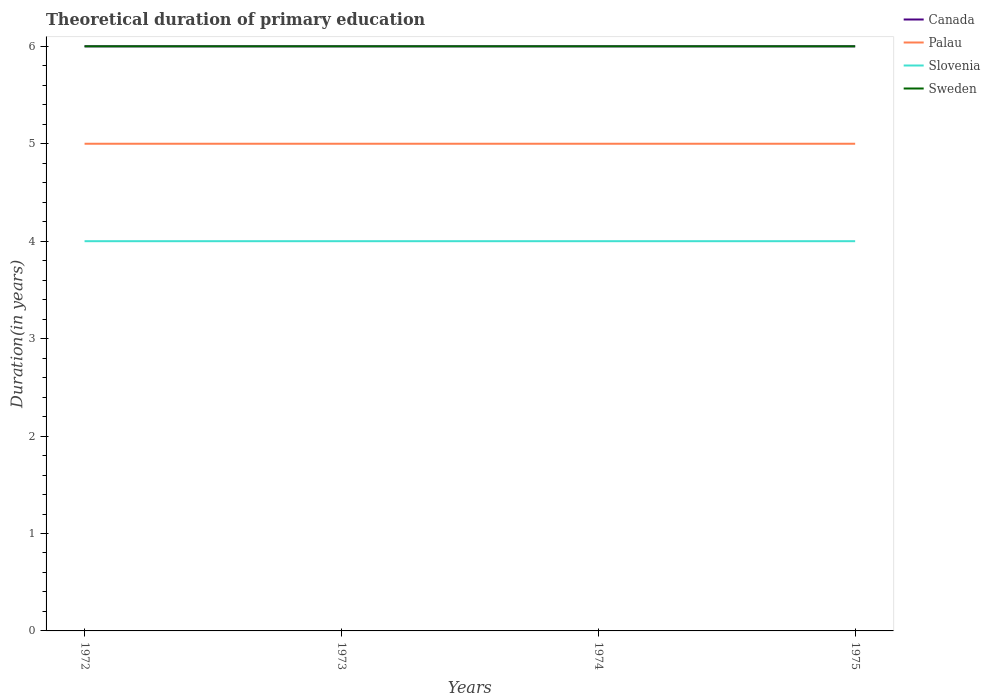How many different coloured lines are there?
Offer a terse response. 4. Does the line corresponding to Canada intersect with the line corresponding to Palau?
Your answer should be compact. No. Is the number of lines equal to the number of legend labels?
Your response must be concise. Yes. What is the total total theoretical duration of primary education in Canada in the graph?
Your answer should be compact. 0. What is the difference between the highest and the second highest total theoretical duration of primary education in Sweden?
Your answer should be compact. 0. What is the difference between the highest and the lowest total theoretical duration of primary education in Slovenia?
Your answer should be very brief. 0. Is the total theoretical duration of primary education in Slovenia strictly greater than the total theoretical duration of primary education in Palau over the years?
Your answer should be very brief. Yes. How many lines are there?
Offer a very short reply. 4. What is the difference between two consecutive major ticks on the Y-axis?
Ensure brevity in your answer.  1. Are the values on the major ticks of Y-axis written in scientific E-notation?
Your answer should be very brief. No. Where does the legend appear in the graph?
Give a very brief answer. Top right. How are the legend labels stacked?
Your response must be concise. Vertical. What is the title of the graph?
Provide a succinct answer. Theoretical duration of primary education. Does "Djibouti" appear as one of the legend labels in the graph?
Your answer should be very brief. No. What is the label or title of the Y-axis?
Ensure brevity in your answer.  Duration(in years). What is the Duration(in years) in Palau in 1972?
Give a very brief answer. 5. What is the Duration(in years) of Canada in 1973?
Your answer should be compact. 6. What is the Duration(in years) in Sweden in 1973?
Make the answer very short. 6. What is the Duration(in years) of Canada in 1974?
Ensure brevity in your answer.  6. What is the Duration(in years) of Palau in 1974?
Keep it short and to the point. 5. What is the Duration(in years) in Canada in 1975?
Ensure brevity in your answer.  6. What is the Duration(in years) of Palau in 1975?
Keep it short and to the point. 5. What is the Duration(in years) of Slovenia in 1975?
Your answer should be compact. 4. Across all years, what is the maximum Duration(in years) of Slovenia?
Make the answer very short. 4. Across all years, what is the minimum Duration(in years) of Palau?
Keep it short and to the point. 5. Across all years, what is the minimum Duration(in years) in Sweden?
Provide a succinct answer. 6. What is the total Duration(in years) of Slovenia in the graph?
Provide a succinct answer. 16. What is the difference between the Duration(in years) in Sweden in 1972 and that in 1973?
Keep it short and to the point. 0. What is the difference between the Duration(in years) in Palau in 1972 and that in 1974?
Your response must be concise. 0. What is the difference between the Duration(in years) of Sweden in 1972 and that in 1974?
Ensure brevity in your answer.  0. What is the difference between the Duration(in years) in Canada in 1973 and that in 1974?
Offer a very short reply. 0. What is the difference between the Duration(in years) of Palau in 1973 and that in 1974?
Your answer should be compact. 0. What is the difference between the Duration(in years) of Slovenia in 1973 and that in 1974?
Make the answer very short. 0. What is the difference between the Duration(in years) in Palau in 1973 and that in 1975?
Provide a short and direct response. 0. What is the difference between the Duration(in years) of Sweden in 1973 and that in 1975?
Provide a short and direct response. 0. What is the difference between the Duration(in years) of Canada in 1974 and that in 1975?
Offer a terse response. 0. What is the difference between the Duration(in years) of Palau in 1974 and that in 1975?
Offer a very short reply. 0. What is the difference between the Duration(in years) of Canada in 1972 and the Duration(in years) of Sweden in 1973?
Provide a short and direct response. 0. What is the difference between the Duration(in years) in Palau in 1972 and the Duration(in years) in Sweden in 1973?
Keep it short and to the point. -1. What is the difference between the Duration(in years) in Slovenia in 1972 and the Duration(in years) in Sweden in 1973?
Keep it short and to the point. -2. What is the difference between the Duration(in years) of Canada in 1972 and the Duration(in years) of Slovenia in 1974?
Your answer should be very brief. 2. What is the difference between the Duration(in years) of Canada in 1972 and the Duration(in years) of Sweden in 1974?
Offer a terse response. 0. What is the difference between the Duration(in years) in Canada in 1972 and the Duration(in years) in Palau in 1975?
Ensure brevity in your answer.  1. What is the difference between the Duration(in years) in Palau in 1972 and the Duration(in years) in Sweden in 1975?
Your response must be concise. -1. What is the difference between the Duration(in years) in Canada in 1973 and the Duration(in years) in Palau in 1974?
Your answer should be very brief. 1. What is the difference between the Duration(in years) in Palau in 1973 and the Duration(in years) in Slovenia in 1974?
Provide a short and direct response. 1. What is the difference between the Duration(in years) of Palau in 1973 and the Duration(in years) of Sweden in 1974?
Provide a short and direct response. -1. What is the difference between the Duration(in years) of Slovenia in 1973 and the Duration(in years) of Sweden in 1974?
Your response must be concise. -2. What is the difference between the Duration(in years) of Canada in 1973 and the Duration(in years) of Palau in 1975?
Provide a succinct answer. 1. What is the difference between the Duration(in years) of Palau in 1973 and the Duration(in years) of Sweden in 1975?
Your answer should be very brief. -1. What is the average Duration(in years) of Palau per year?
Offer a very short reply. 5. In the year 1972, what is the difference between the Duration(in years) of Canada and Duration(in years) of Palau?
Make the answer very short. 1. In the year 1972, what is the difference between the Duration(in years) of Palau and Duration(in years) of Slovenia?
Provide a short and direct response. 1. In the year 1972, what is the difference between the Duration(in years) in Palau and Duration(in years) in Sweden?
Offer a terse response. -1. In the year 1972, what is the difference between the Duration(in years) in Slovenia and Duration(in years) in Sweden?
Offer a very short reply. -2. In the year 1974, what is the difference between the Duration(in years) in Canada and Duration(in years) in Slovenia?
Your answer should be compact. 2. In the year 1974, what is the difference between the Duration(in years) in Canada and Duration(in years) in Sweden?
Your response must be concise. 0. In the year 1974, what is the difference between the Duration(in years) in Palau and Duration(in years) in Slovenia?
Offer a very short reply. 1. In the year 1974, what is the difference between the Duration(in years) of Palau and Duration(in years) of Sweden?
Your response must be concise. -1. In the year 1974, what is the difference between the Duration(in years) in Slovenia and Duration(in years) in Sweden?
Provide a succinct answer. -2. In the year 1975, what is the difference between the Duration(in years) of Canada and Duration(in years) of Slovenia?
Your answer should be very brief. 2. In the year 1975, what is the difference between the Duration(in years) in Palau and Duration(in years) in Sweden?
Offer a terse response. -1. In the year 1975, what is the difference between the Duration(in years) of Slovenia and Duration(in years) of Sweden?
Keep it short and to the point. -2. What is the ratio of the Duration(in years) of Canada in 1972 to that in 1973?
Make the answer very short. 1. What is the ratio of the Duration(in years) in Sweden in 1972 to that in 1973?
Offer a terse response. 1. What is the ratio of the Duration(in years) in Palau in 1972 to that in 1974?
Your response must be concise. 1. What is the ratio of the Duration(in years) in Slovenia in 1972 to that in 1974?
Offer a terse response. 1. What is the ratio of the Duration(in years) in Sweden in 1972 to that in 1974?
Your answer should be very brief. 1. What is the ratio of the Duration(in years) of Palau in 1972 to that in 1975?
Give a very brief answer. 1. What is the ratio of the Duration(in years) of Canada in 1973 to that in 1974?
Provide a succinct answer. 1. What is the ratio of the Duration(in years) of Sweden in 1973 to that in 1974?
Make the answer very short. 1. What is the ratio of the Duration(in years) of Canada in 1973 to that in 1975?
Give a very brief answer. 1. What is the ratio of the Duration(in years) of Slovenia in 1973 to that in 1975?
Give a very brief answer. 1. What is the ratio of the Duration(in years) of Sweden in 1973 to that in 1975?
Your answer should be very brief. 1. What is the ratio of the Duration(in years) of Canada in 1974 to that in 1975?
Ensure brevity in your answer.  1. What is the ratio of the Duration(in years) in Palau in 1974 to that in 1975?
Provide a short and direct response. 1. What is the ratio of the Duration(in years) in Sweden in 1974 to that in 1975?
Keep it short and to the point. 1. What is the difference between the highest and the second highest Duration(in years) in Canada?
Your answer should be very brief. 0. What is the difference between the highest and the second highest Duration(in years) in Sweden?
Your answer should be compact. 0. What is the difference between the highest and the lowest Duration(in years) of Sweden?
Your response must be concise. 0. 